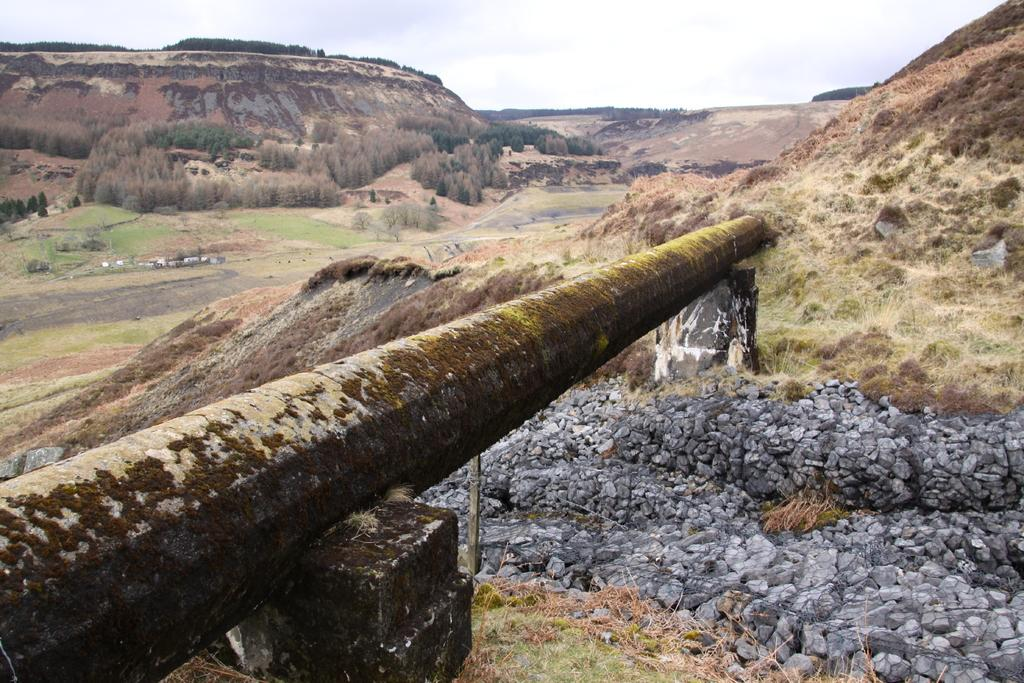What type of landform can be seen in the image? There is a hill in the image. What kind of vegetation is present in the image? There are many trees in the image. What material is used for the stones on the right side of the image? The stones on the right side of the image are made of concrete. What is visible at the top of the image? The sky is visible at the top of the image. What can be seen in the sky in the image? Clouds are present in the sky. How many grapes are hanging from the trees in the image? There are no grapes visible in the image; the trees are not fruit-bearing trees. What type of cub is playing with the concrete stones in the image? There is no cub present in the image; the stones are not associated with any animal or creature. 